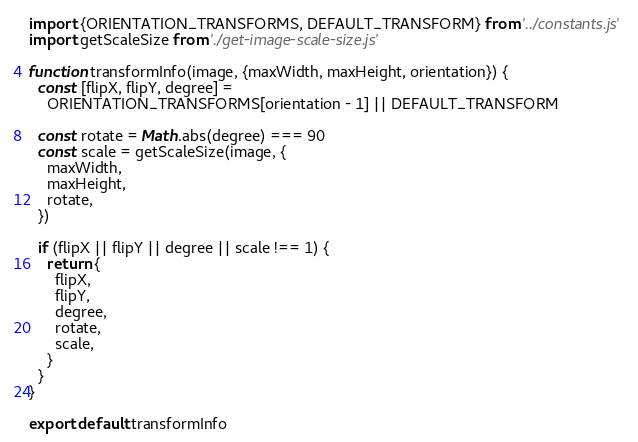Convert code to text. <code><loc_0><loc_0><loc_500><loc_500><_JavaScript_>import {ORIENTATION_TRANSFORMS, DEFAULT_TRANSFORM} from '../constants.js'
import getScaleSize from './get-image-scale-size.js'

function transformInfo(image, {maxWidth, maxHeight, orientation}) {
  const [flipX, flipY, degree] =
    ORIENTATION_TRANSFORMS[orientation - 1] || DEFAULT_TRANSFORM

  const rotate = Math.abs(degree) === 90
  const scale = getScaleSize(image, {
    maxWidth,
    maxHeight,
    rotate,
  })

  if (flipX || flipY || degree || scale !== 1) {
    return {
      flipX,
      flipY,
      degree,
      rotate,
      scale,
    }
  }
}

export default transformInfo
</code> 